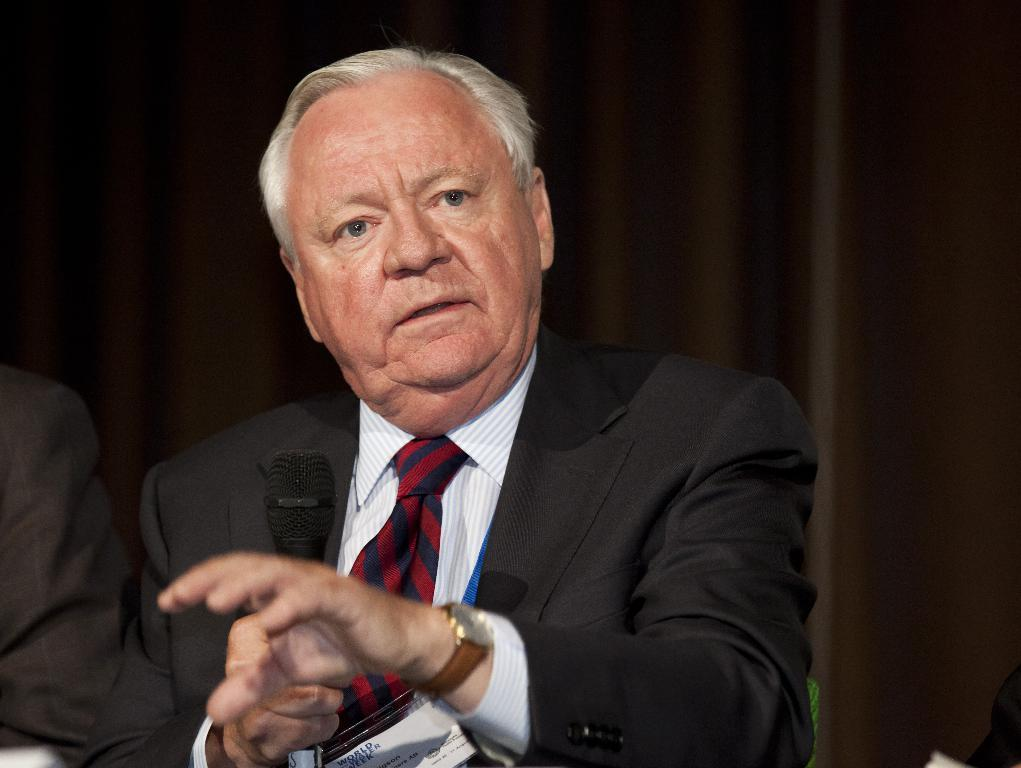Who can be seen in the image? There are people in the image. Can you describe the man in the middle of the image? The man in the middle of the image is holding a microphone. What is the man wearing? The man is wearing a black color suit. Is the man in the image swimming in a pool? No, the man is not swimming in a pool; he is holding a microphone and wearing a suit, which suggests a different context. 